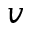<formula> <loc_0><loc_0><loc_500><loc_500>v</formula> 